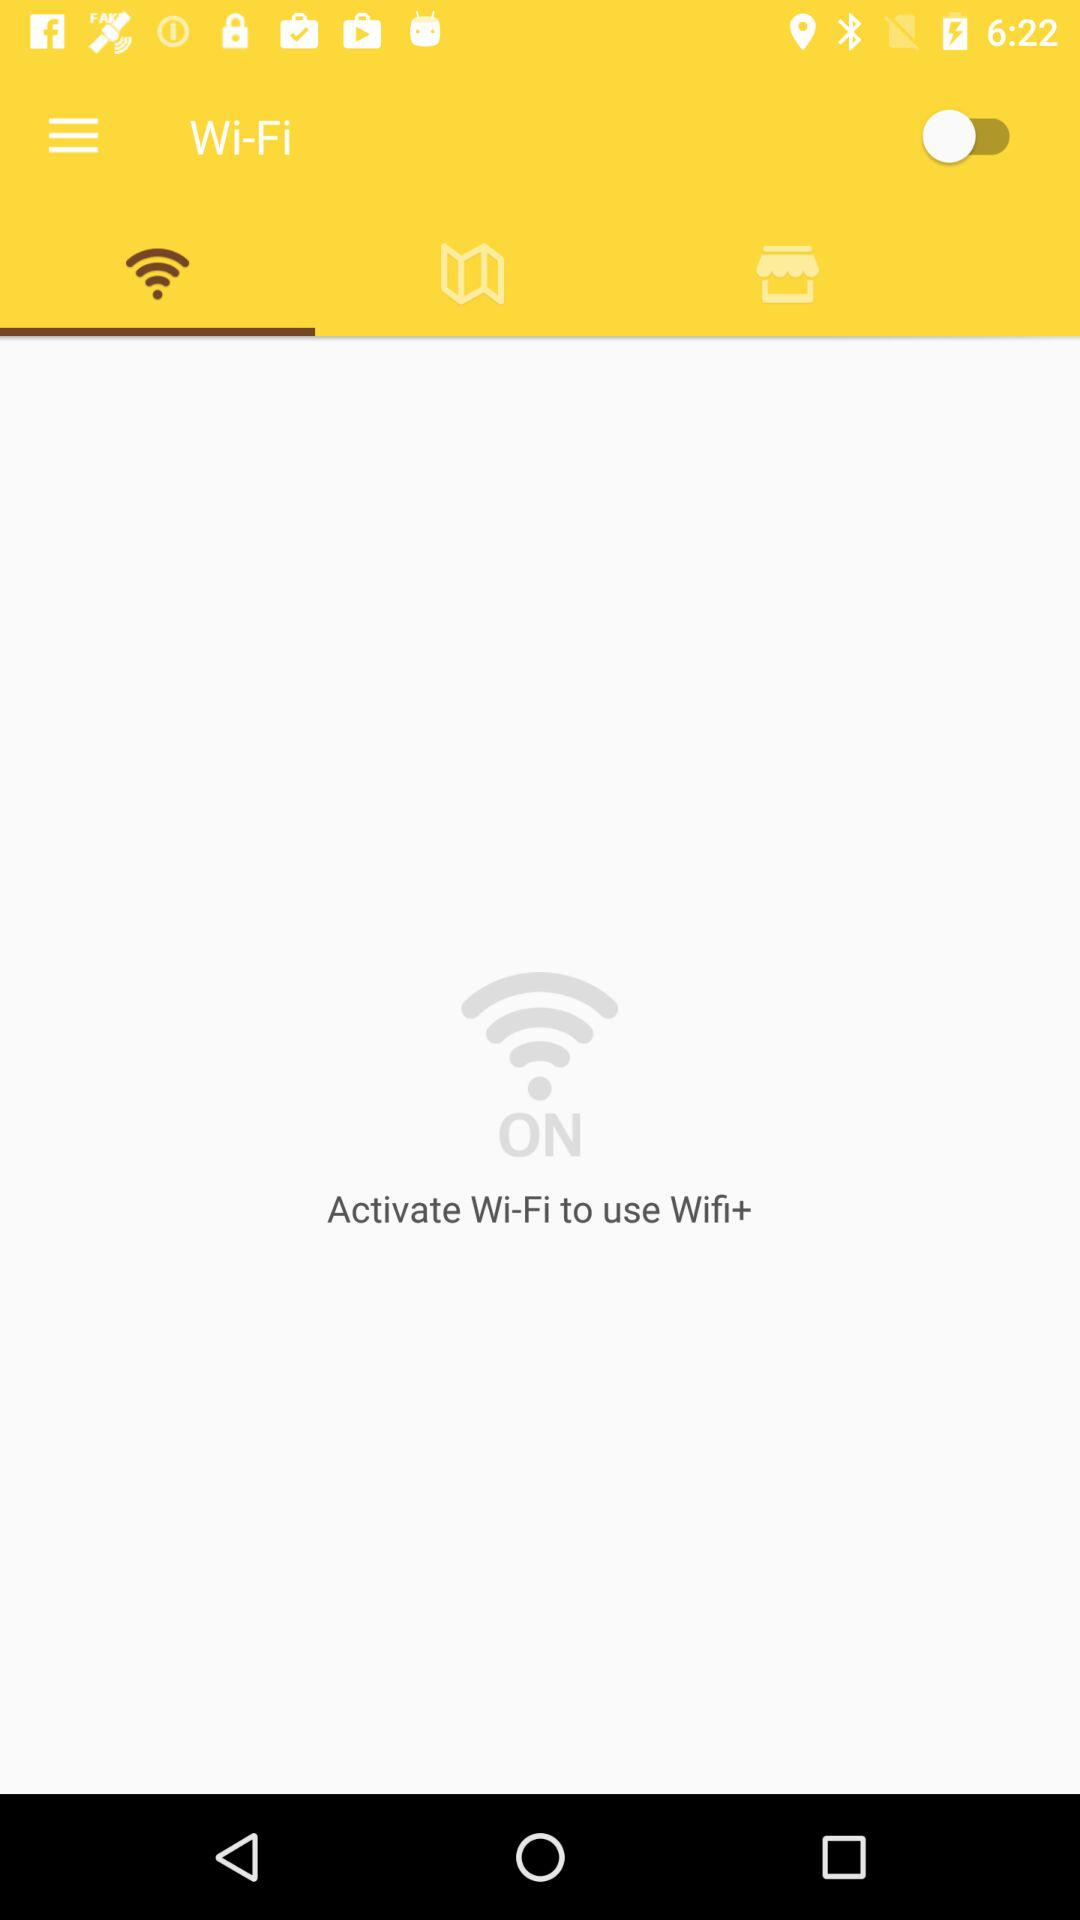What is the status of Wi-Fi? The status is "off". 